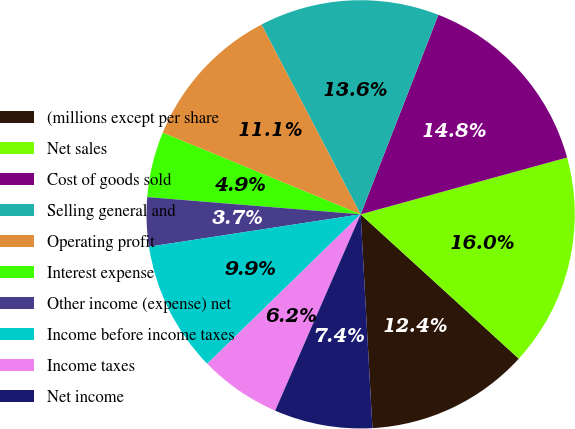<chart> <loc_0><loc_0><loc_500><loc_500><pie_chart><fcel>(millions except per share<fcel>Net sales<fcel>Cost of goods sold<fcel>Selling general and<fcel>Operating profit<fcel>Interest expense<fcel>Other income (expense) net<fcel>Income before income taxes<fcel>Income taxes<fcel>Net income<nl><fcel>12.35%<fcel>16.05%<fcel>14.81%<fcel>13.58%<fcel>11.11%<fcel>4.94%<fcel>3.7%<fcel>9.88%<fcel>6.17%<fcel>7.41%<nl></chart> 